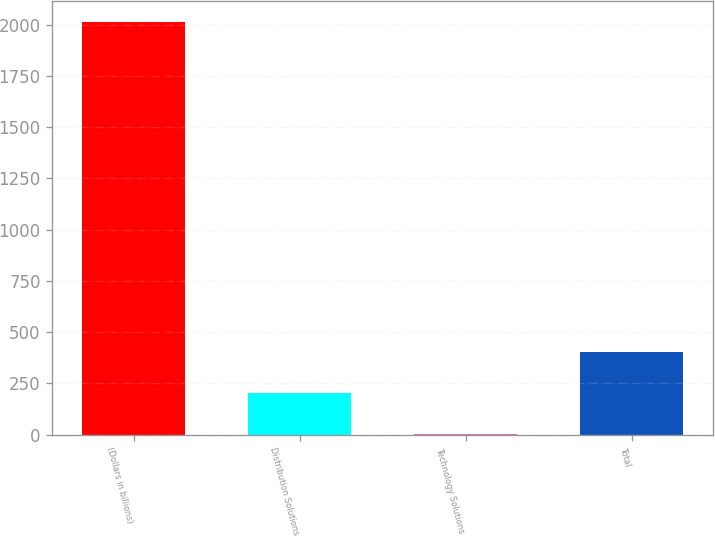Convert chart. <chart><loc_0><loc_0><loc_500><loc_500><bar_chart><fcel>(Dollars in billions)<fcel>Distribution Solutions<fcel>Technology Solutions<fcel>Total<nl><fcel>2013<fcel>203.1<fcel>2<fcel>404.2<nl></chart> 